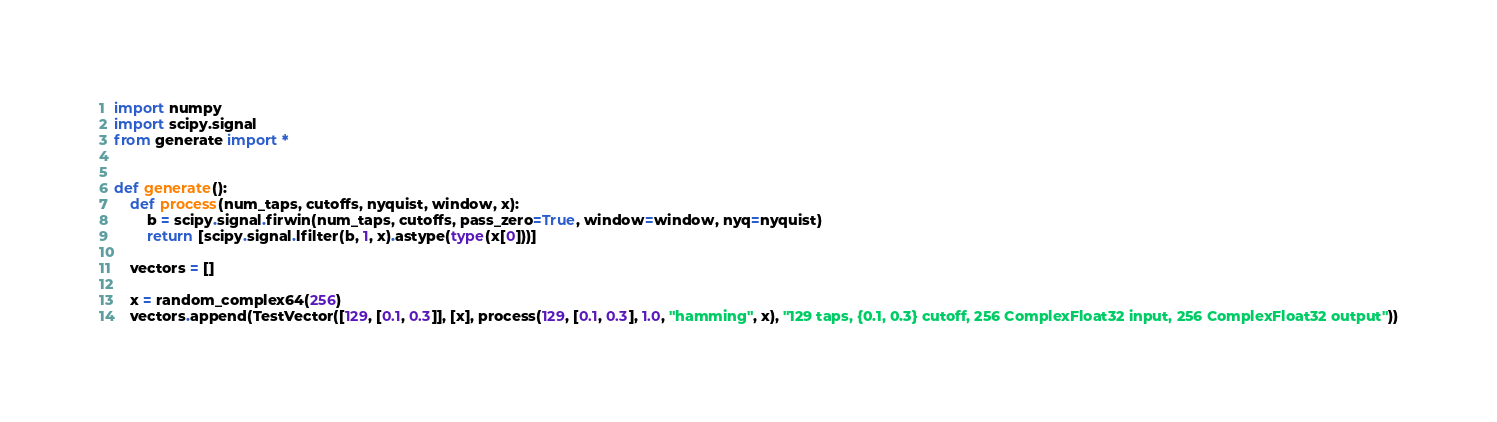<code> <loc_0><loc_0><loc_500><loc_500><_Python_>import numpy
import scipy.signal
from generate import *


def generate():
    def process(num_taps, cutoffs, nyquist, window, x):
        b = scipy.signal.firwin(num_taps, cutoffs, pass_zero=True, window=window, nyq=nyquist)
        return [scipy.signal.lfilter(b, 1, x).astype(type(x[0]))]

    vectors = []

    x = random_complex64(256)
    vectors.append(TestVector([129, [0.1, 0.3]], [x], process(129, [0.1, 0.3], 1.0, "hamming", x), "129 taps, {0.1, 0.3} cutoff, 256 ComplexFloat32 input, 256 ComplexFloat32 output"))</code> 